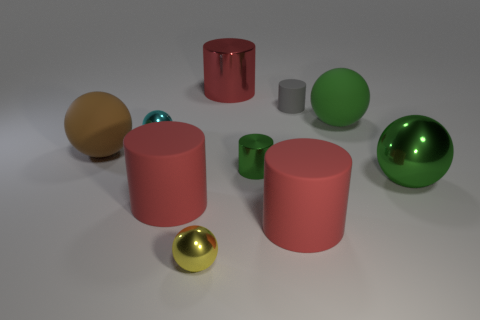How many green balls must be subtracted to get 1 green balls? 1 Subtract all purple spheres. How many red cylinders are left? 3 Subtract 1 balls. How many balls are left? 4 Subtract all yellow balls. How many balls are left? 4 Subtract all yellow metallic balls. How many balls are left? 4 Subtract all brown cylinders. Subtract all brown spheres. How many cylinders are left? 5 Subtract 0 brown cylinders. How many objects are left? 10 Subtract all gray balls. Subtract all small metal objects. How many objects are left? 7 Add 9 small green things. How many small green things are left? 10 Add 3 big gray balls. How many big gray balls exist? 3 